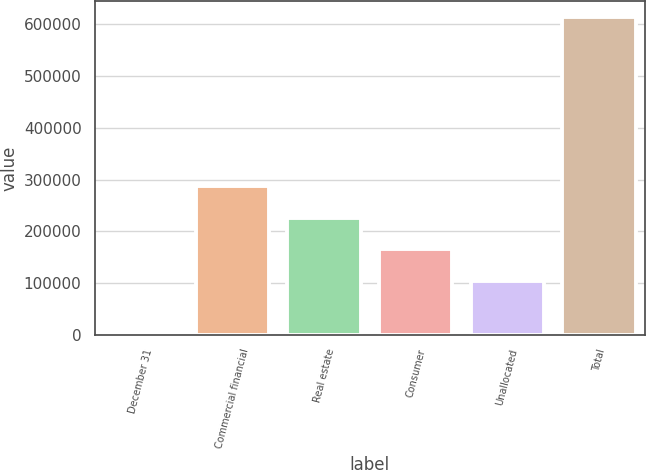Convert chart. <chart><loc_0><loc_0><loc_500><loc_500><bar_chart><fcel>December 31<fcel>Commercial financial<fcel>Real estate<fcel>Consumer<fcel>Unallocated<fcel>Total<nl><fcel>2003<fcel>287520<fcel>226315<fcel>165110<fcel>103904<fcel>614058<nl></chart> 